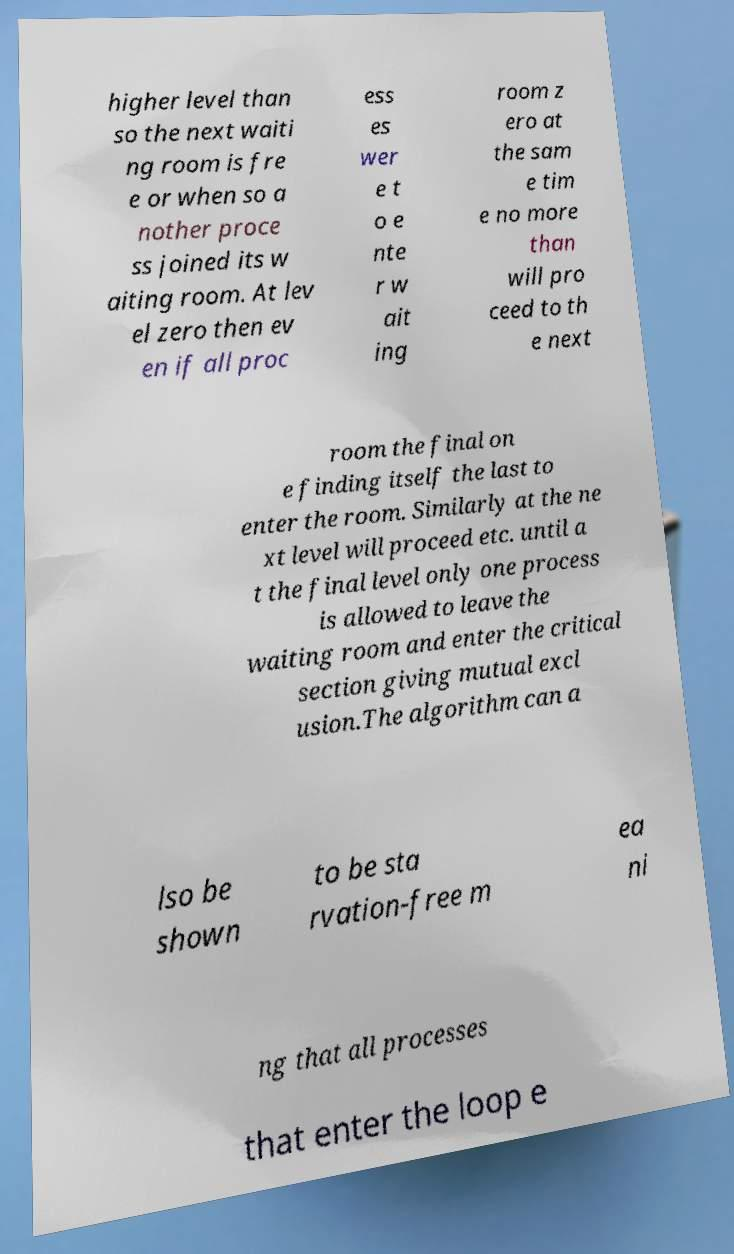For documentation purposes, I need the text within this image transcribed. Could you provide that? higher level than so the next waiti ng room is fre e or when so a nother proce ss joined its w aiting room. At lev el zero then ev en if all proc ess es wer e t o e nte r w ait ing room z ero at the sam e tim e no more than will pro ceed to th e next room the final on e finding itself the last to enter the room. Similarly at the ne xt level will proceed etc. until a t the final level only one process is allowed to leave the waiting room and enter the critical section giving mutual excl usion.The algorithm can a lso be shown to be sta rvation-free m ea ni ng that all processes that enter the loop e 